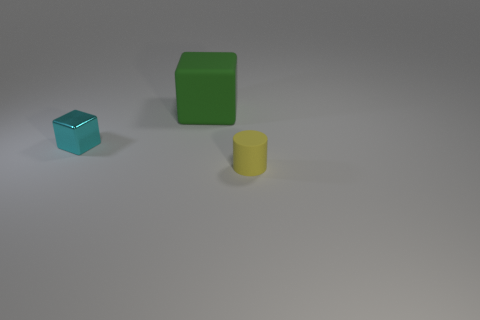Is there anything else that has the same size as the green block?
Your answer should be compact. No. Is there anything else that has the same material as the cyan block?
Ensure brevity in your answer.  No. How many things are objects that are to the right of the green thing or tiny objects that are in front of the cyan metal cube?
Your answer should be very brief. 1. What number of tiny cyan metal things are the same shape as the big thing?
Your response must be concise. 1. There is a object that is right of the cyan block and behind the yellow matte object; what is it made of?
Your answer should be very brief. Rubber. There is a shiny block; how many tiny objects are on the right side of it?
Offer a terse response. 1. What number of yellow rubber cylinders are there?
Ensure brevity in your answer.  1. Is the cyan metallic block the same size as the green rubber block?
Ensure brevity in your answer.  No. Are there any things that are in front of the matte thing that is behind the tiny thing to the right of the small metallic cube?
Offer a very short reply. Yes. There is a small object that is the same shape as the big green rubber thing; what is it made of?
Ensure brevity in your answer.  Metal. 